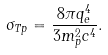<formula> <loc_0><loc_0><loc_500><loc_500>\sigma _ { T p } = \frac { 8 \pi q ^ { 4 } _ { e } } { 3 m ^ { 2 } _ { p } c ^ { 4 } } .</formula> 